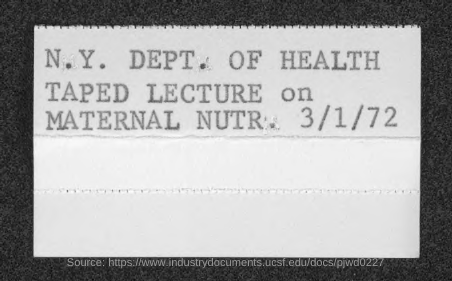What is the date mentioned?
Give a very brief answer. 3/1/72. 